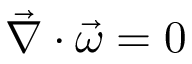<formula> <loc_0><loc_0><loc_500><loc_500>\vec { \nabla } \cdot \vec { \omega } = 0</formula> 